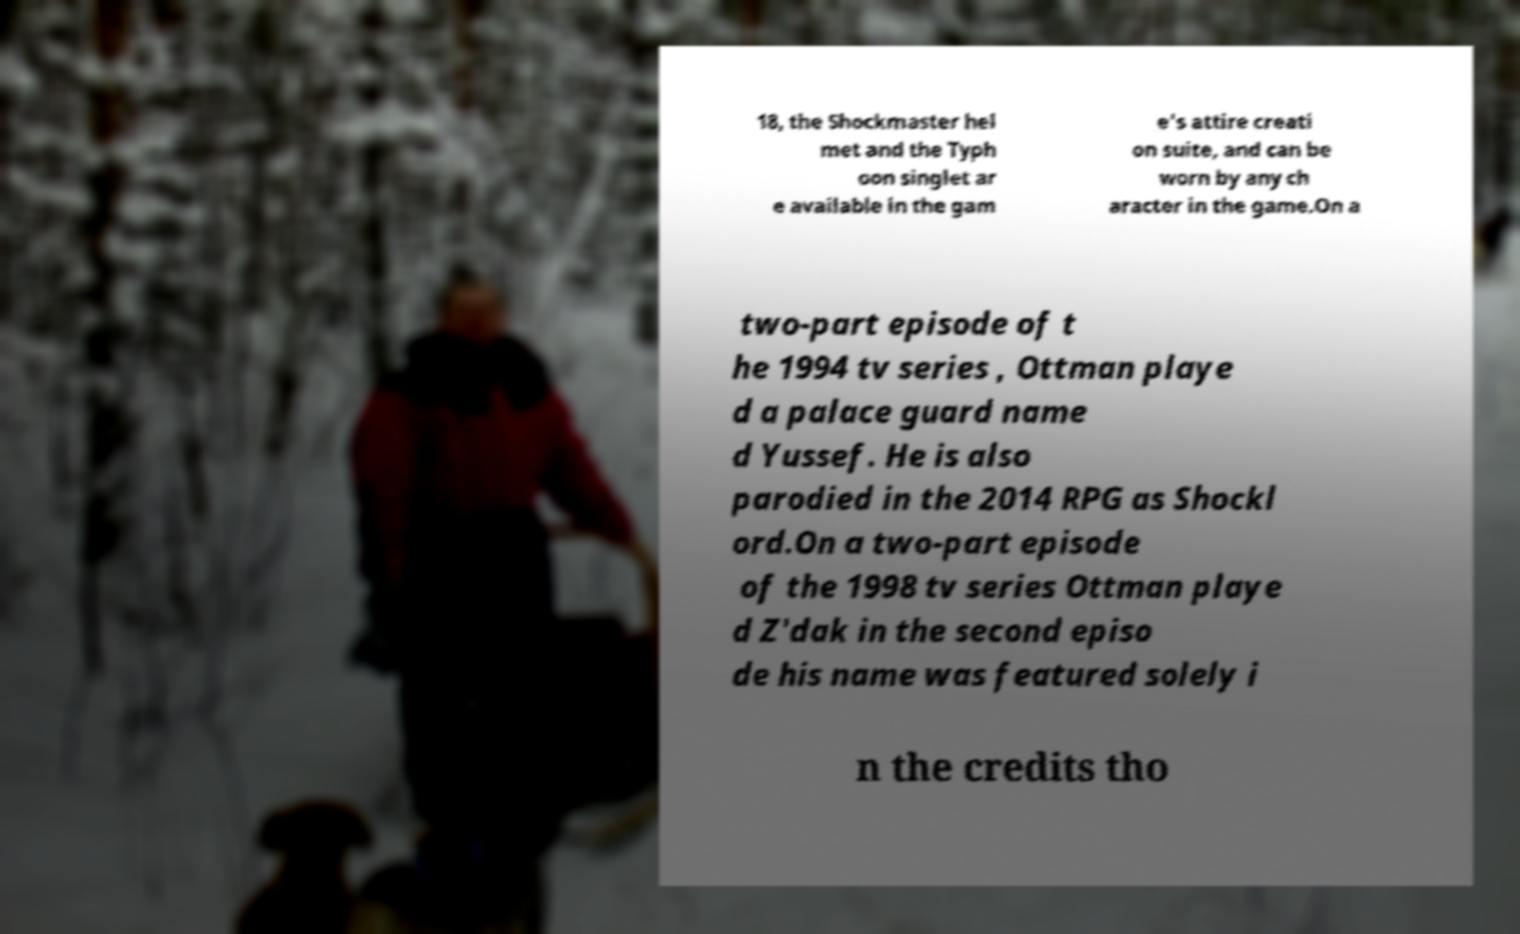Could you assist in decoding the text presented in this image and type it out clearly? 18, the Shockmaster hel met and the Typh oon singlet ar e available in the gam e's attire creati on suite, and can be worn by any ch aracter in the game.On a two-part episode of t he 1994 tv series , Ottman playe d a palace guard name d Yussef. He is also parodied in the 2014 RPG as Shockl ord.On a two-part episode of the 1998 tv series Ottman playe d Z'dak in the second episo de his name was featured solely i n the credits tho 